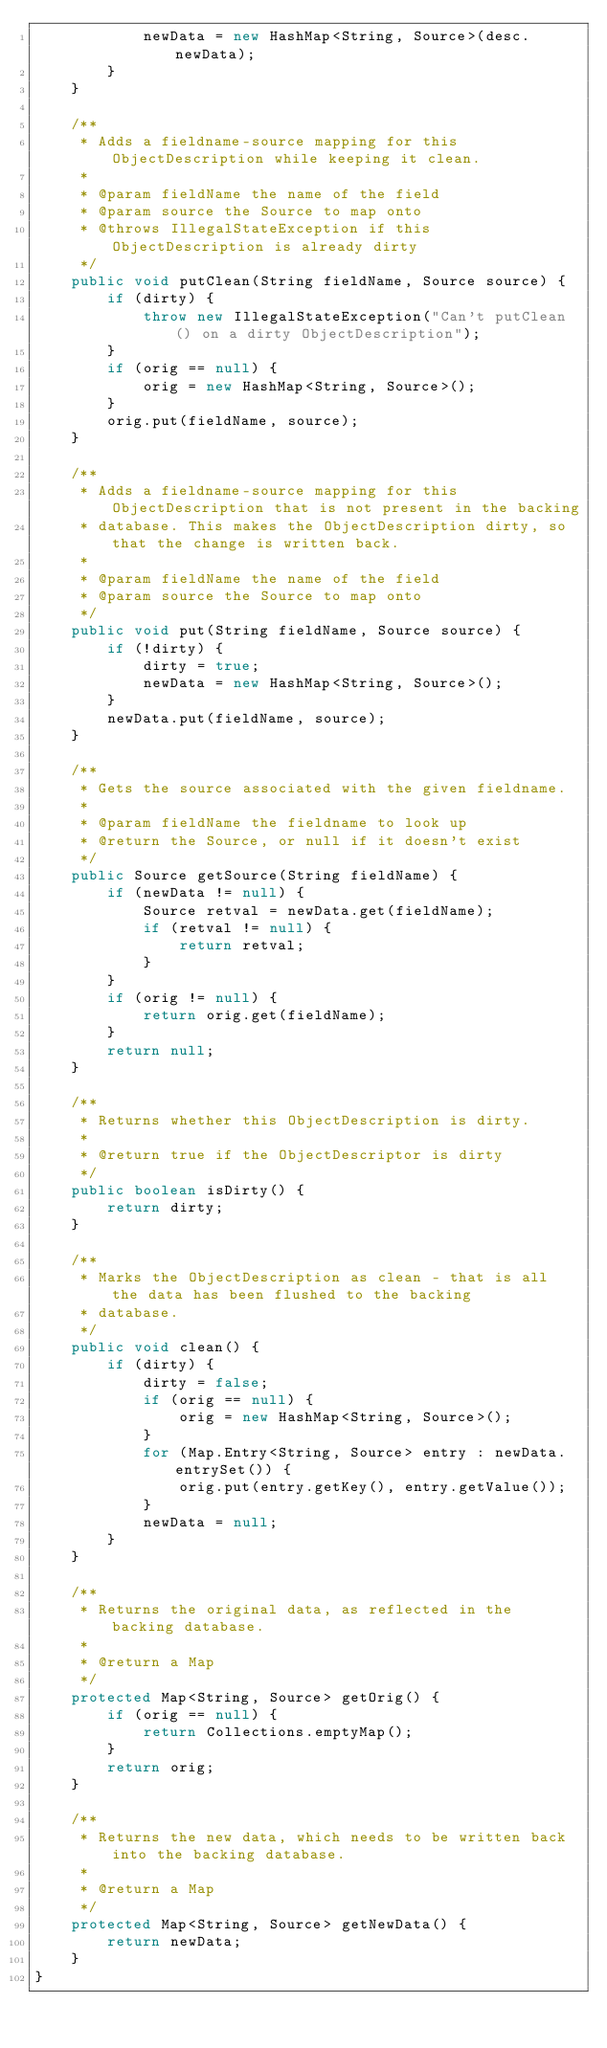Convert code to text. <code><loc_0><loc_0><loc_500><loc_500><_Java_>            newData = new HashMap<String, Source>(desc.newData);
        }
    }

    /**
     * Adds a fieldname-source mapping for this ObjectDescription while keeping it clean.
     *
     * @param fieldName the name of the field
     * @param source the Source to map onto
     * @throws IllegalStateException if this ObjectDescription is already dirty
     */
    public void putClean(String fieldName, Source source) {
        if (dirty) {
            throw new IllegalStateException("Can't putClean() on a dirty ObjectDescription");
        }
        if (orig == null) {
            orig = new HashMap<String, Source>();
        }
        orig.put(fieldName, source);
    }

    /**
     * Adds a fieldname-source mapping for this ObjectDescription that is not present in the backing
     * database. This makes the ObjectDescription dirty, so that the change is written back.
     *
     * @param fieldName the name of the field
     * @param source the Source to map onto
     */
    public void put(String fieldName, Source source) {
        if (!dirty) {
            dirty = true;
            newData = new HashMap<String, Source>();
        }
        newData.put(fieldName, source);
    }

    /**
     * Gets the source associated with the given fieldname.
     *
     * @param fieldName the fieldname to look up
     * @return the Source, or null if it doesn't exist
     */
    public Source getSource(String fieldName) {
        if (newData != null) {
            Source retval = newData.get(fieldName);
            if (retval != null) {
                return retval;
            }
        }
        if (orig != null) {
            return orig.get(fieldName);
        }
        return null;
    }

    /**
     * Returns whether this ObjectDescription is dirty.
     *
     * @return true if the ObjectDescriptor is dirty
     */
    public boolean isDirty() {
        return dirty;
    }

    /**
     * Marks the ObjectDescription as clean - that is all the data has been flushed to the backing
     * database.
     */
    public void clean() {
        if (dirty) {
            dirty = false;
            if (orig == null) {
                orig = new HashMap<String, Source>();
            }
            for (Map.Entry<String, Source> entry : newData.entrySet()) {
                orig.put(entry.getKey(), entry.getValue());
            }
            newData = null;
        }
    }

    /**
     * Returns the original data, as reflected in the backing database.
     *
     * @return a Map
     */
    protected Map<String, Source> getOrig() {
        if (orig == null) {
            return Collections.emptyMap();
        }
        return orig;
    }

    /**
     * Returns the new data, which needs to be written back into the backing database.
     *
     * @return a Map
     */
    protected Map<String, Source> getNewData() {
        return newData;
    }
}
</code> 